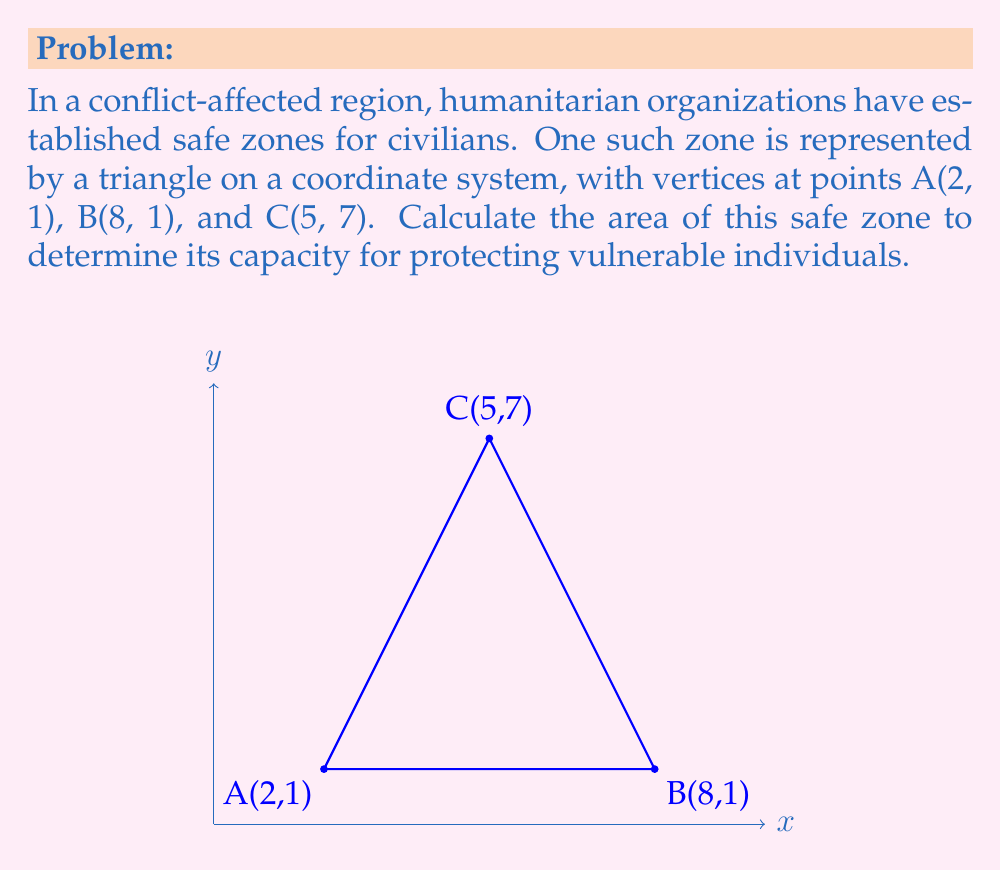Give your solution to this math problem. To calculate the area of the triangular safe zone, we can use the formula for the area of a triangle given the coordinates of its vertices:

$$ \text{Area} = \frac{1}{2}|x_1(y_2 - y_3) + x_2(y_3 - y_1) + x_3(y_1 - y_2)| $$

Where $(x_1, y_1)$, $(x_2, y_2)$, and $(x_3, y_3)$ are the coordinates of the three vertices.

Step 1: Identify the coordinates
A(2, 1), B(8, 1), C(5, 7)

Step 2: Substitute the values into the formula
$$ \text{Area} = \frac{1}{2}|2(1 - 7) + 8(7 - 1) + 5(1 - 1)| $$

Step 3: Simplify the expressions inside the parentheses
$$ \text{Area} = \frac{1}{2}|2(-6) + 8(6) + 5(0)| $$

Step 4: Multiply
$$ \text{Area} = \frac{1}{2}|-12 + 48 + 0| $$

Step 5: Add the terms inside the absolute value brackets
$$ \text{Area} = \frac{1}{2}|36| $$

Step 6: Evaluate the absolute value
$$ \text{Area} = \frac{1}{2}(36) $$

Step 7: Calculate the final result
$$ \text{Area} = 18 $$

The area of the safe zone is 18 square units.
Answer: 18 square units 